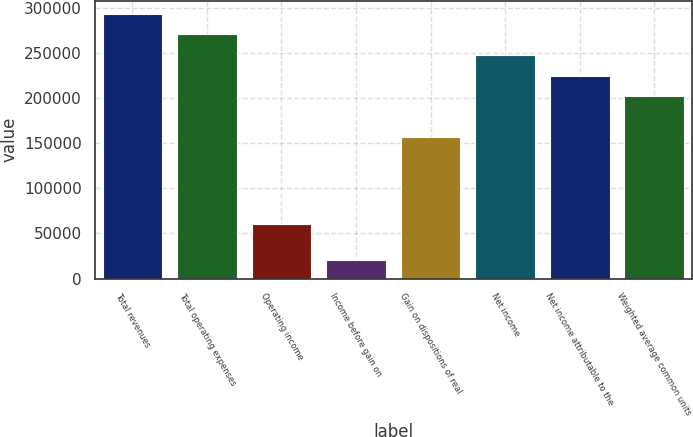<chart> <loc_0><loc_0><loc_500><loc_500><bar_chart><fcel>Total revenues<fcel>Total operating expenses<fcel>Operating income<fcel>Income before gain on<fcel>Gain on dispositions of real<fcel>Net income<fcel>Net income attributable to the<fcel>Weighted average common units<nl><fcel>293759<fcel>270893<fcel>60094<fcel>20835<fcel>156564<fcel>248027<fcel>225161<fcel>202296<nl></chart> 